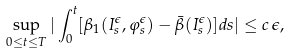<formula> <loc_0><loc_0><loc_500><loc_500>\sup _ { 0 \leq t \leq T } | \int _ { 0 } ^ { t } [ \beta _ { 1 } ( I _ { s } ^ { \epsilon } , \varphi _ { s } ^ { \epsilon } ) - \bar { \beta } ( I _ { s } ^ { \epsilon } ) ] d s | \leq c \, \epsilon ,</formula> 